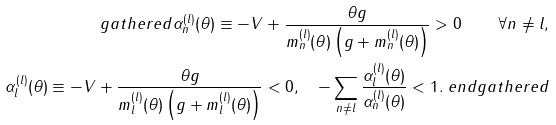<formula> <loc_0><loc_0><loc_500><loc_500>\ g a t h e r e d \alpha _ { n } ^ { ( l ) } ( \theta ) \equiv - V + \frac { \theta g } { m _ { n } ^ { ( l ) } ( \theta ) \left ( g + m _ { n } ^ { ( l ) } ( \theta ) \right ) } > 0 \quad \forall n \ne l , \\ \alpha _ { l } ^ { ( l ) } ( \theta ) \equiv - V + \frac { \theta g } { m _ { l } ^ { ( l ) } ( \theta ) \left ( g + m _ { l } ^ { ( l ) } ( \theta ) \right ) } < 0 , \quad - \sum _ { n \ne l } \frac { \alpha _ { l } ^ { ( l ) } ( \theta ) } { \alpha _ { n } ^ { ( l ) } ( \theta ) } < 1 . \ e n d g a t h e r e d</formula> 